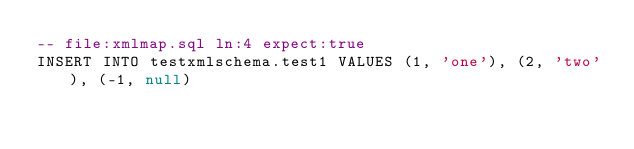Convert code to text. <code><loc_0><loc_0><loc_500><loc_500><_SQL_>-- file:xmlmap.sql ln:4 expect:true
INSERT INTO testxmlschema.test1 VALUES (1, 'one'), (2, 'two'), (-1, null)
</code> 